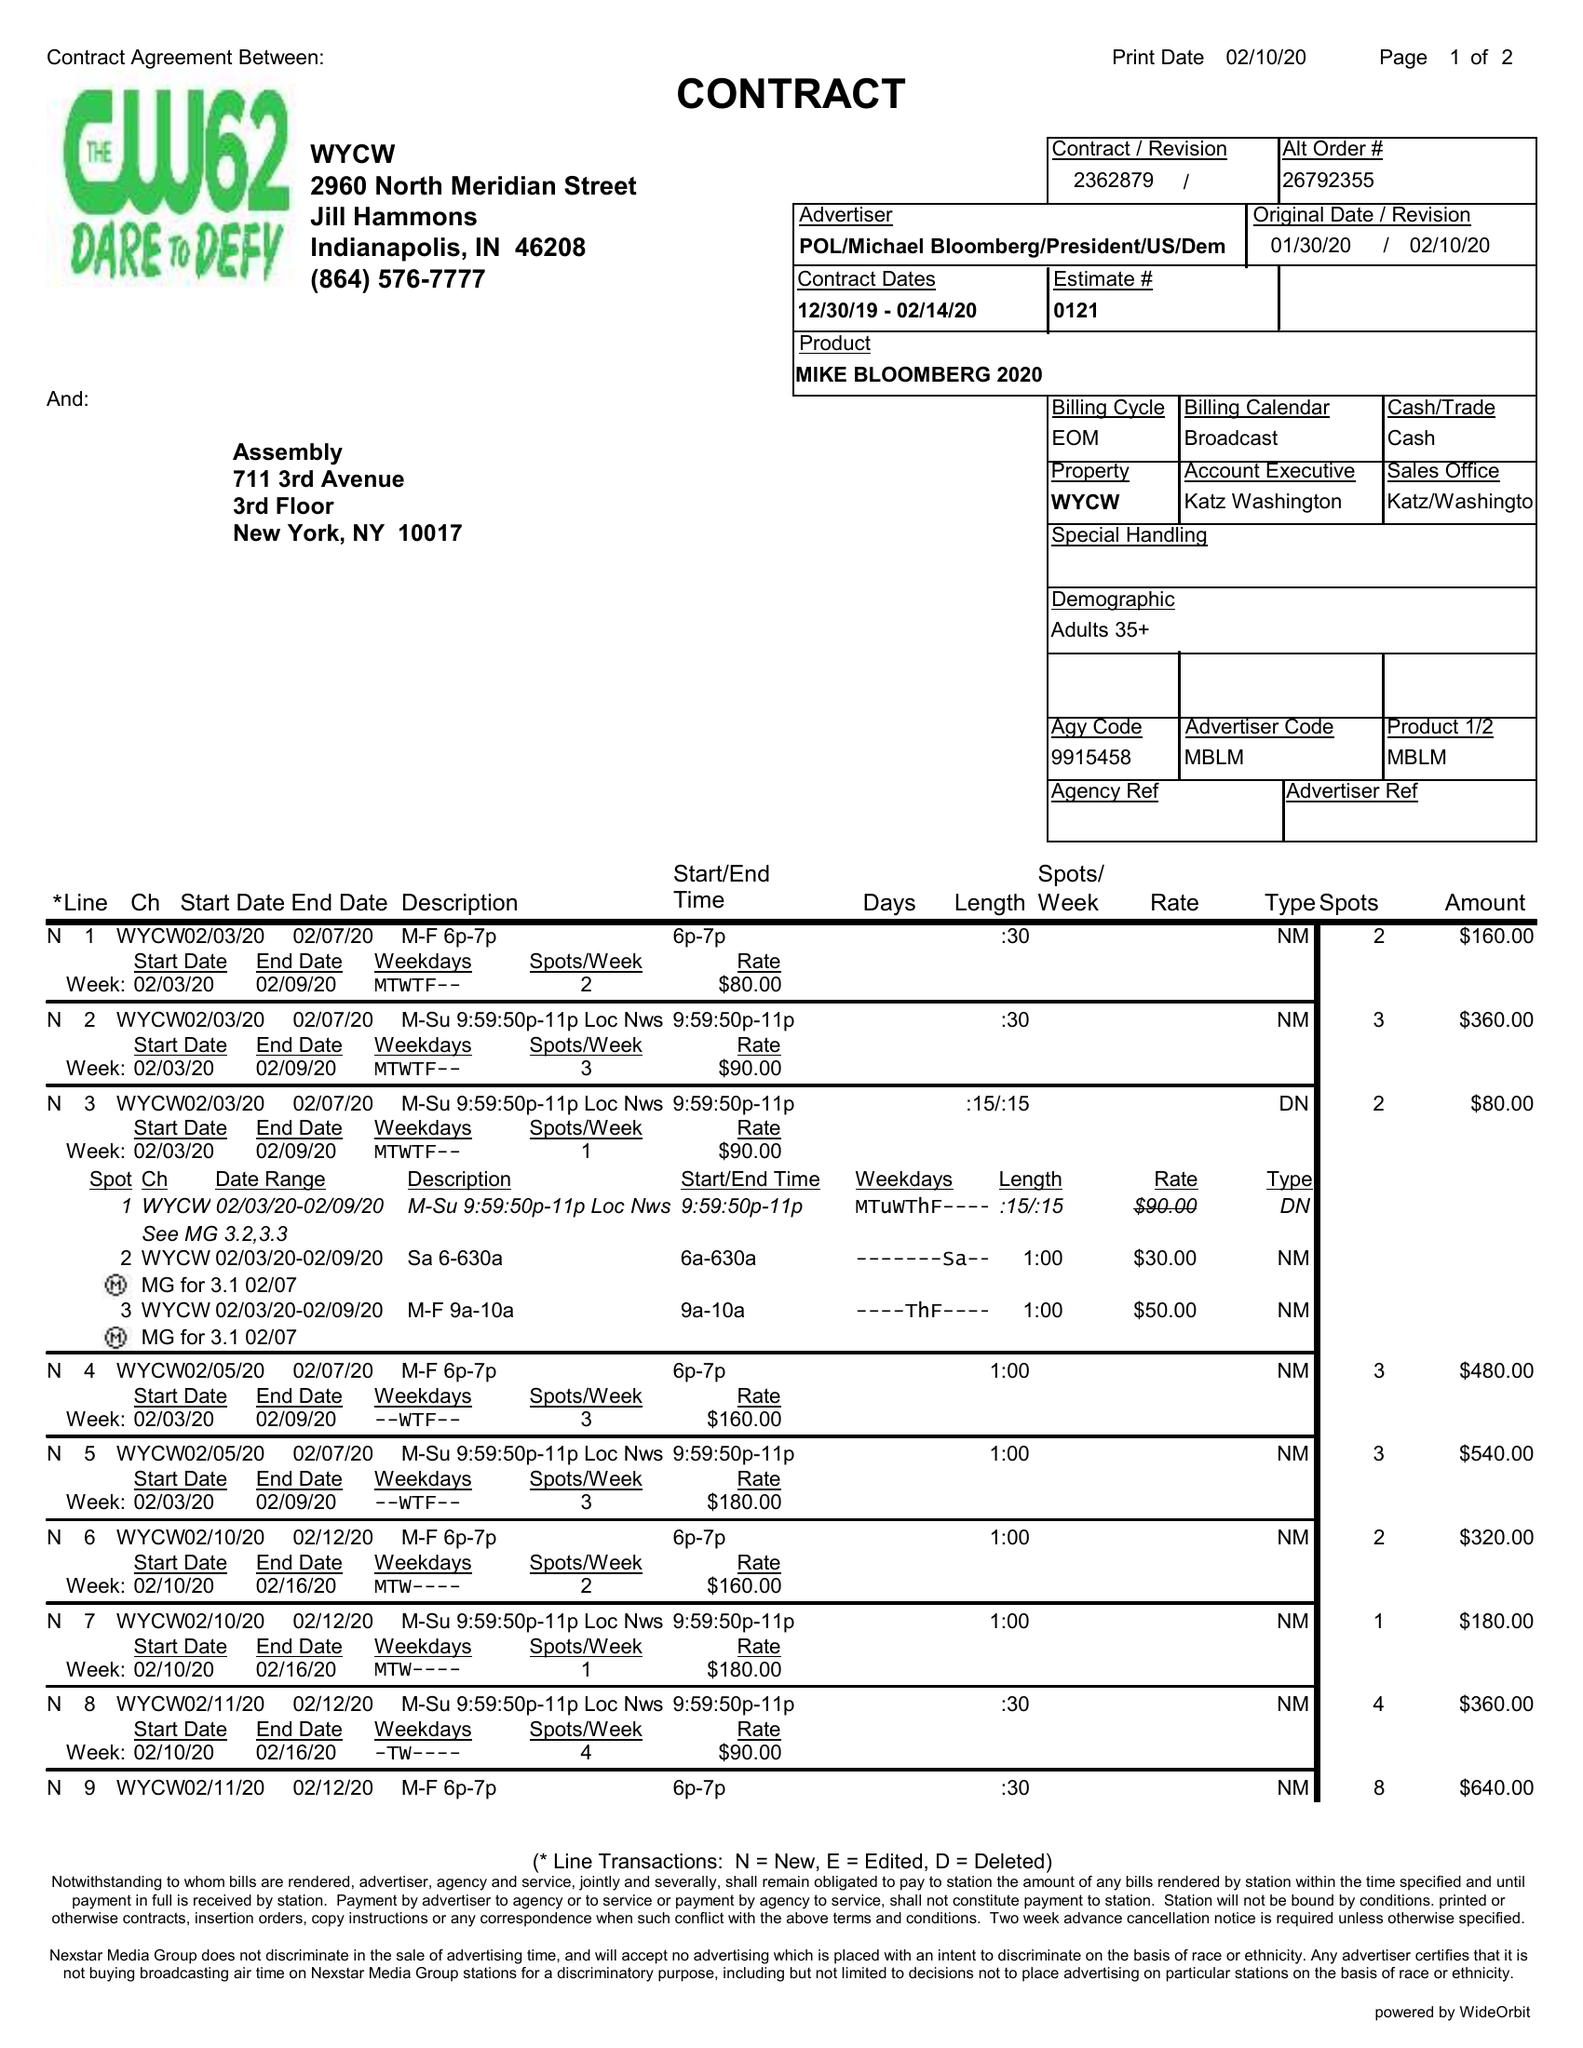What is the value for the flight_to?
Answer the question using a single word or phrase. 02/14/20 